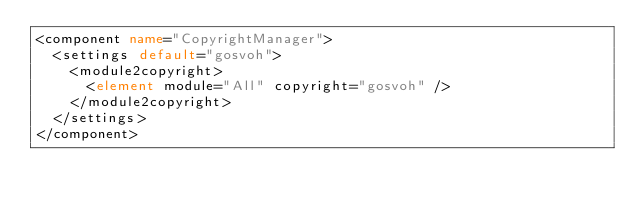<code> <loc_0><loc_0><loc_500><loc_500><_XML_><component name="CopyrightManager">
  <settings default="gosvoh">
    <module2copyright>
      <element module="All" copyright="gosvoh" />
    </module2copyright>
  </settings>
</component></code> 